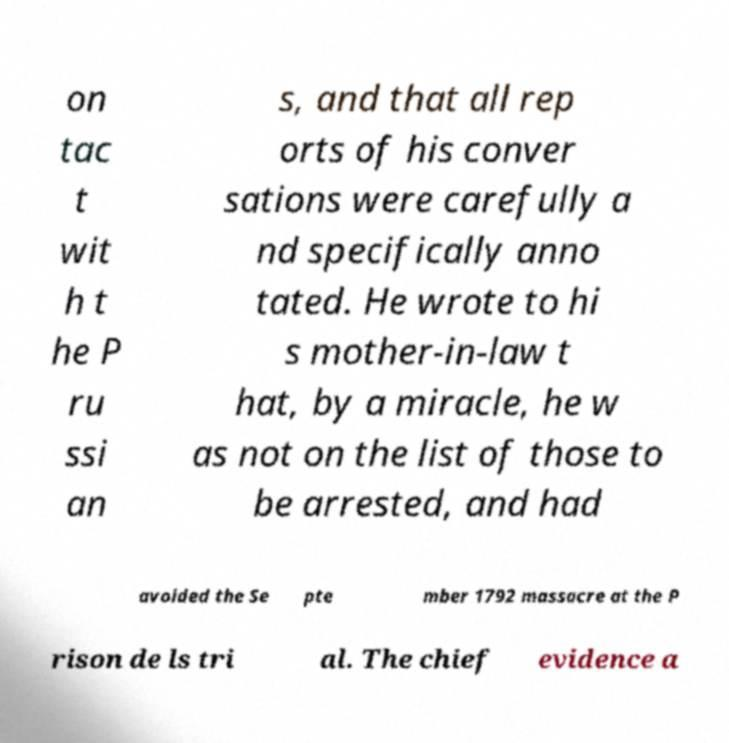Can you accurately transcribe the text from the provided image for me? on tac t wit h t he P ru ssi an s, and that all rep orts of his conver sations were carefully a nd specifically anno tated. He wrote to hi s mother-in-law t hat, by a miracle, he w as not on the list of those to be arrested, and had avoided the Se pte mber 1792 massacre at the P rison de ls tri al. The chief evidence a 